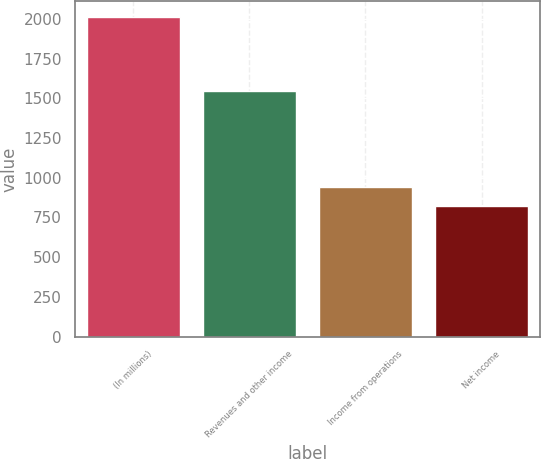<chart> <loc_0><loc_0><loc_500><loc_500><bar_chart><fcel>(In millions)<fcel>Revenues and other income<fcel>Income from operations<fcel>Net income<nl><fcel>2011<fcel>1544<fcel>942<fcel>820<nl></chart> 